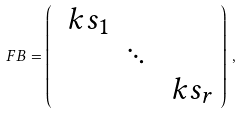<formula> <loc_0><loc_0><loc_500><loc_500>\ F B = \left ( \begin{array} { c c c } \ k s _ { 1 } \\ & \ddots \\ & & \ k s _ { r } \end{array} \right ) \, ,</formula> 